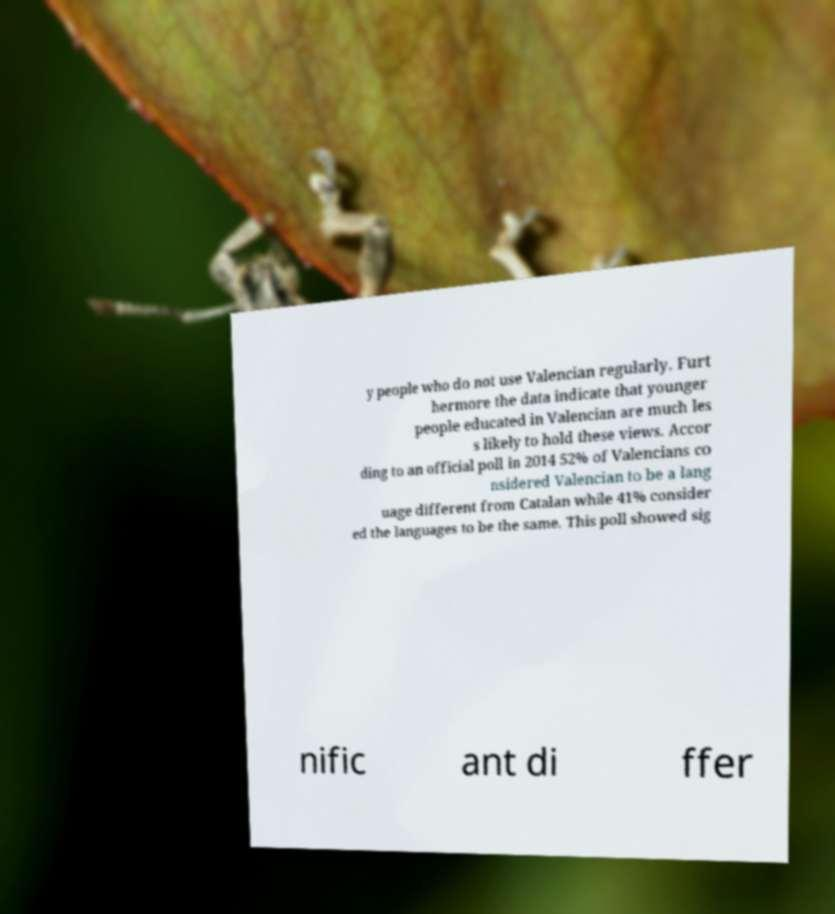Could you extract and type out the text from this image? y people who do not use Valencian regularly. Furt hermore the data indicate that younger people educated in Valencian are much les s likely to hold these views. Accor ding to an official poll in 2014 52% of Valencians co nsidered Valencian to be a lang uage different from Catalan while 41% consider ed the languages to be the same. This poll showed sig nific ant di ffer 